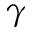<formula> <loc_0><loc_0><loc_500><loc_500>\gamma</formula> 